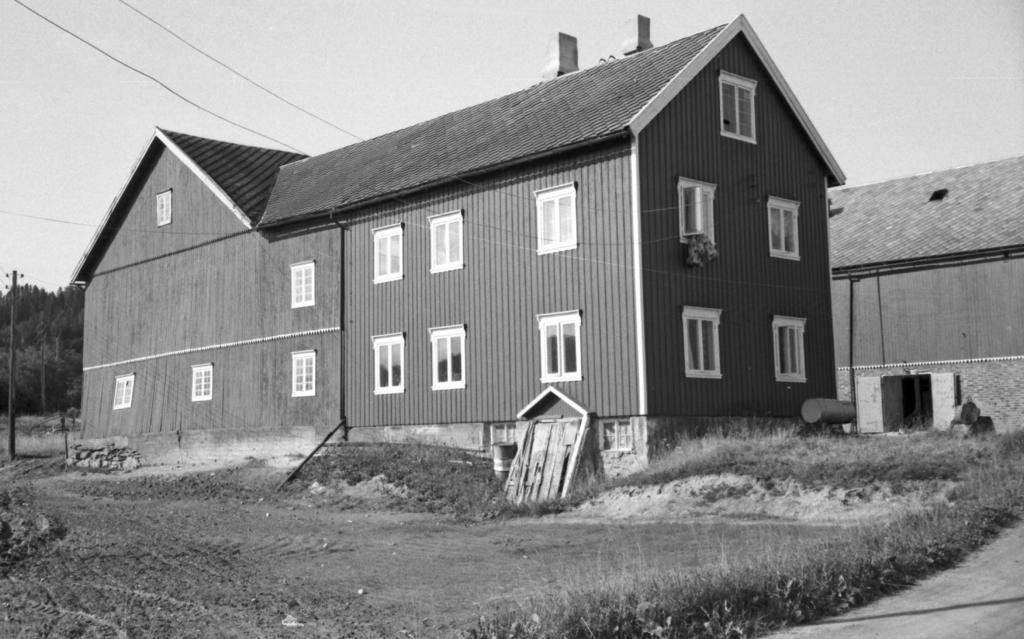What is the color scheme of the image? The image is in black and white. What can be seen in the foreground of the image? There is grass and buildings in the foreground of the image. What is visible in the background of the image? There is a pole, trees, cables, and the sky in the background of the image. What is the purpose of the hose in the image? There is no hose present in the image. Can you tell me when the birth of the tree in the image occurred? There is no tree in the image, so it is not possible to determine when its birth occurred. 